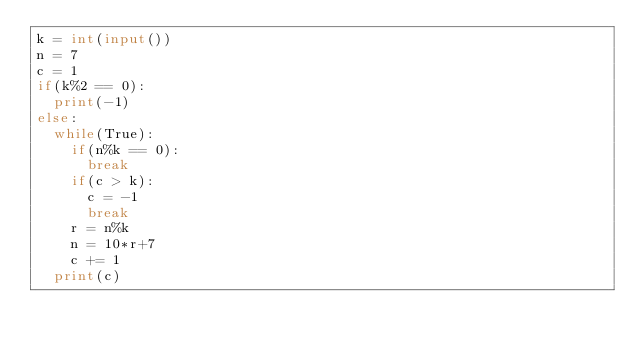Convert code to text. <code><loc_0><loc_0><loc_500><loc_500><_Python_>k = int(input())
n = 7
c = 1
if(k%2 == 0):
  print(-1)
else:
  while(True):
    if(n%k == 0):
      break
    if(c > k):
      c = -1
      break
    r = n%k
    n = 10*r+7
    c += 1
  print(c)</code> 